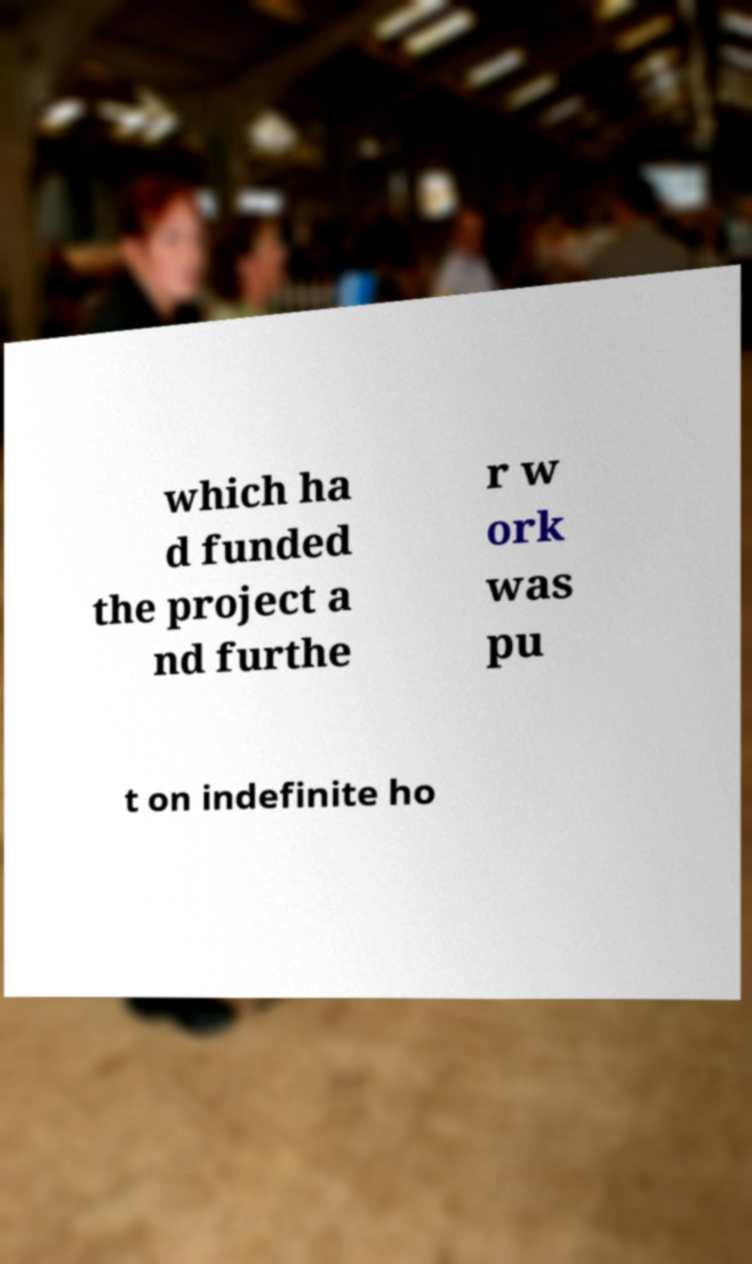Please read and relay the text visible in this image. What does it say? which ha d funded the project a nd furthe r w ork was pu t on indefinite ho 